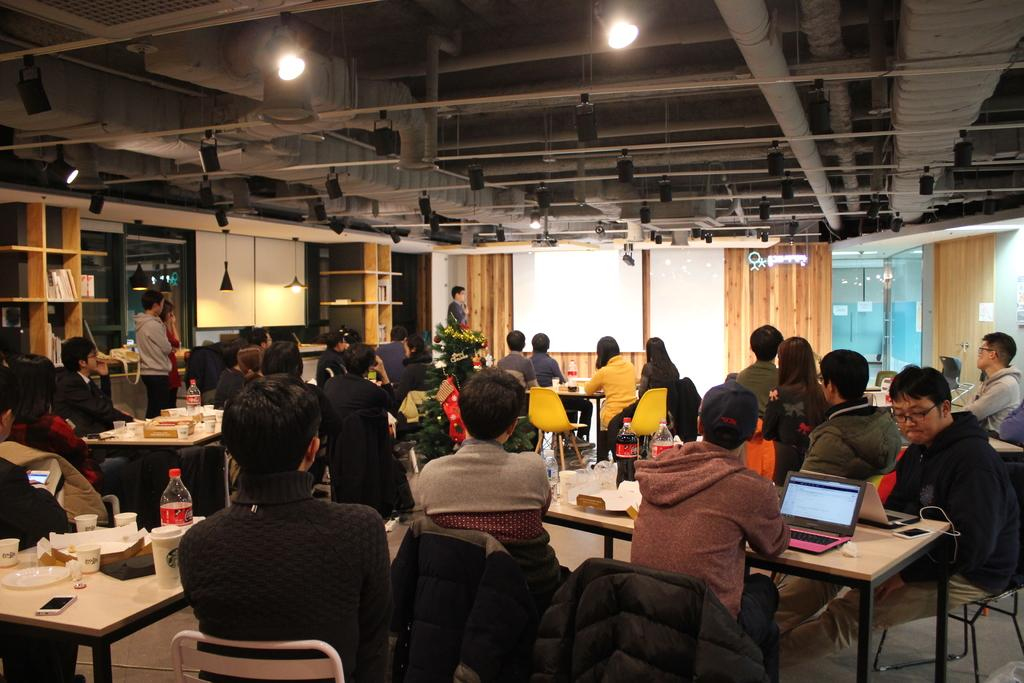What are the people in the image doing? People are sitting in groups at tables. What is the man in the image doing? A man is giving a presentation. What is used to display visual information during the presentation? There is a screen present. What type of behavior is exhibited by the people on the sidewalk in the image? There is no sidewalk present in the image, so we cannot comment on the behavior of people on a sidewalk. 